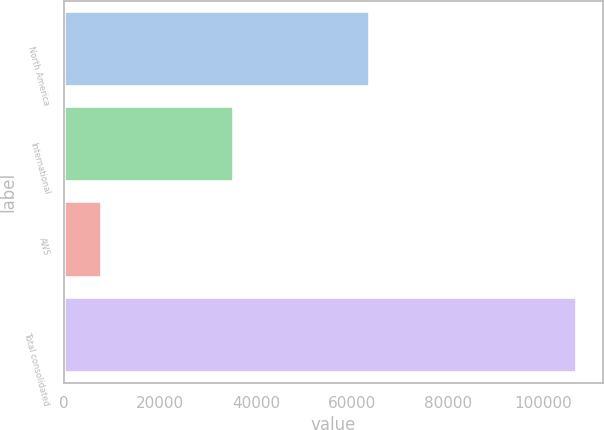Convert chart to OTSL. <chart><loc_0><loc_0><loc_500><loc_500><bar_chart><fcel>North America<fcel>International<fcel>AWS<fcel>Total consolidated<nl><fcel>63708<fcel>35418<fcel>7880<fcel>107006<nl></chart> 